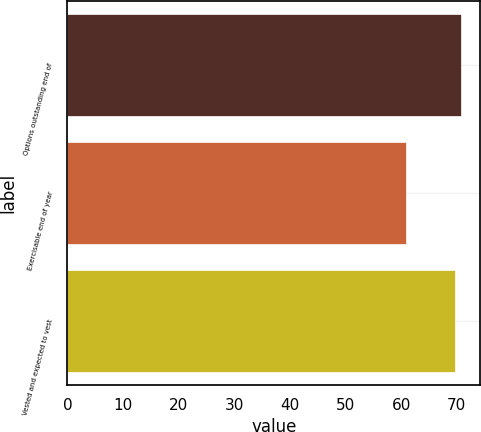Convert chart. <chart><loc_0><loc_0><loc_500><loc_500><bar_chart><fcel>Options outstanding end of<fcel>Exercisable end of year<fcel>Vested and expected to vest<nl><fcel>70.66<fcel>60.81<fcel>69.73<nl></chart> 